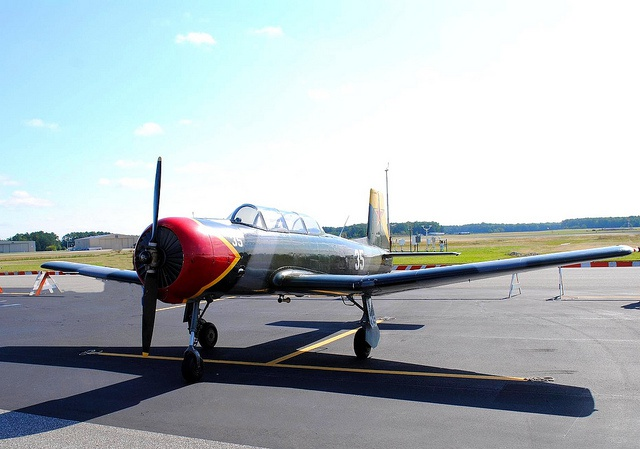Describe the objects in this image and their specific colors. I can see a airplane in lightblue, black, white, gray, and darkgray tones in this image. 